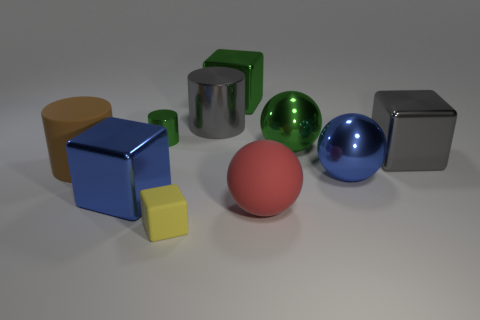Subtract all balls. How many objects are left? 7 Subtract all large yellow rubber objects. Subtract all big things. How many objects are left? 2 Add 6 rubber objects. How many rubber objects are left? 9 Add 5 tiny yellow matte things. How many tiny yellow matte things exist? 6 Subtract 1 green cubes. How many objects are left? 9 